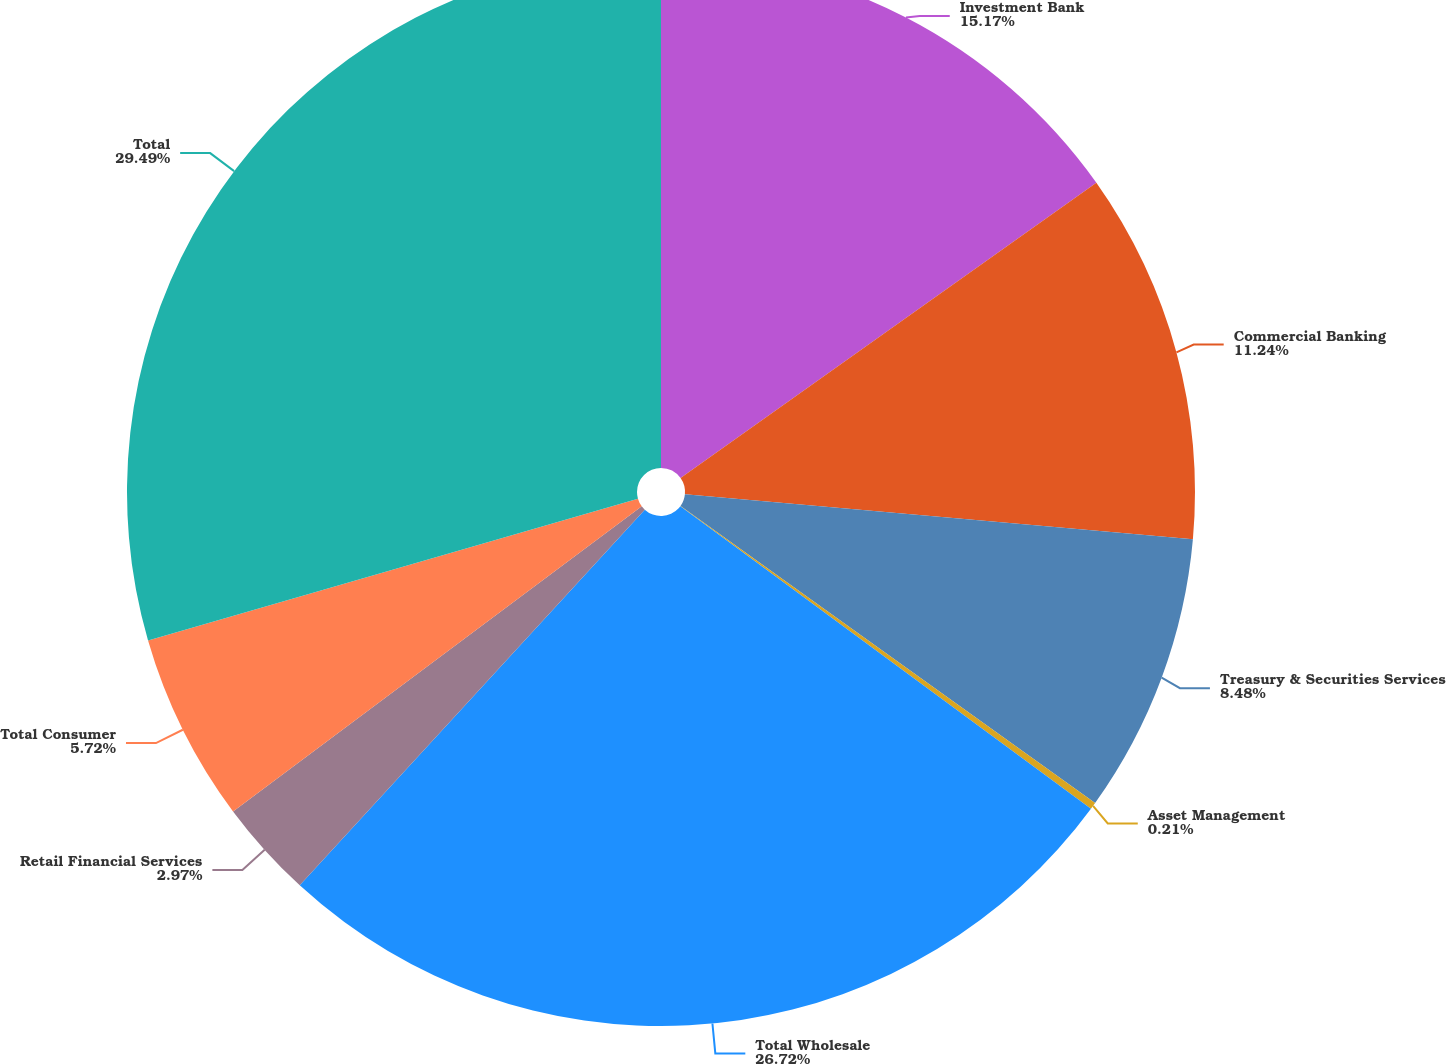<chart> <loc_0><loc_0><loc_500><loc_500><pie_chart><fcel>Investment Bank<fcel>Commercial Banking<fcel>Treasury & Securities Services<fcel>Asset Management<fcel>Total Wholesale<fcel>Retail Financial Services<fcel>Total Consumer<fcel>Total<nl><fcel>15.17%<fcel>11.24%<fcel>8.48%<fcel>0.21%<fcel>26.72%<fcel>2.97%<fcel>5.72%<fcel>29.48%<nl></chart> 